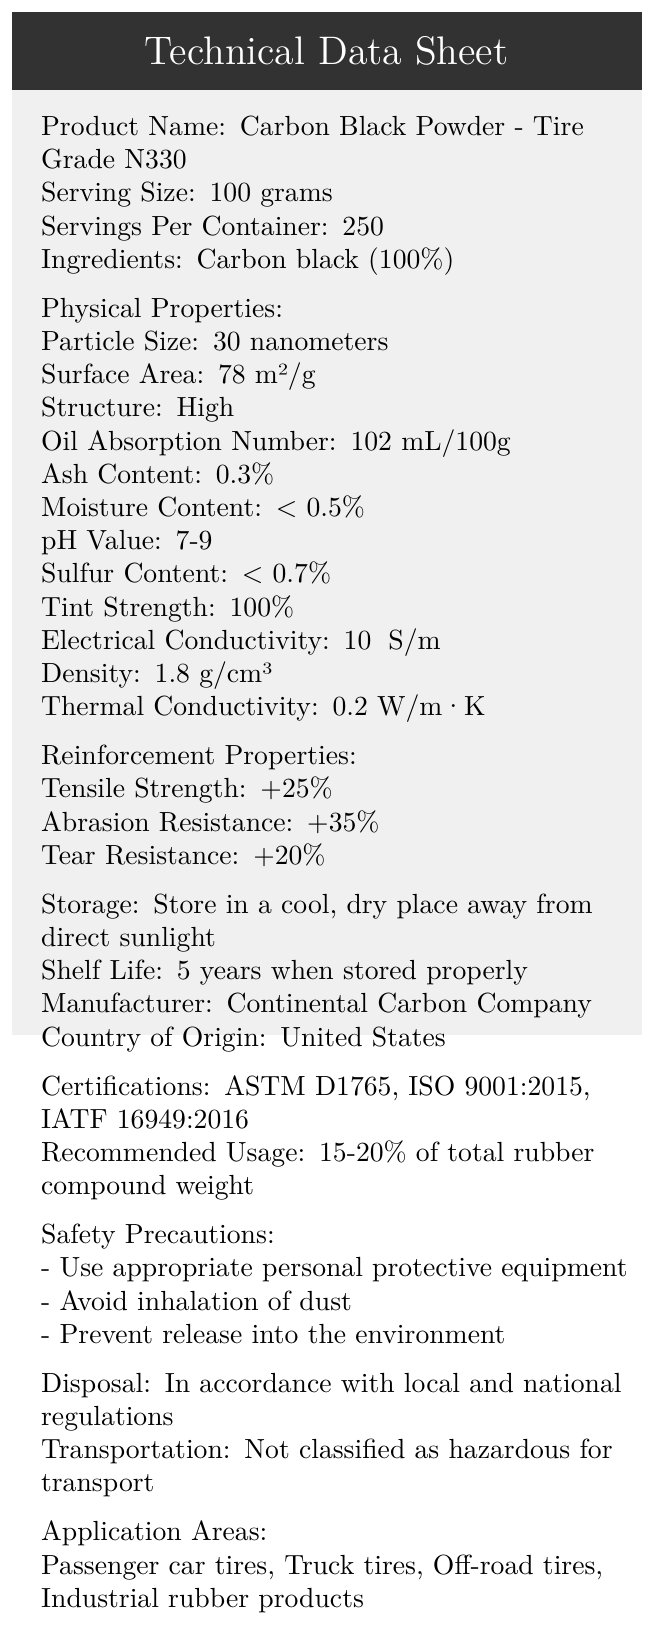what is the product name? The product name is clearly stated at the beginning of the document.
Answer: Carbon Black Powder - Tire Grade N330 what is the particle size of the carbon black powder? The particle size is specified in the document under the Physical Properties section.
Answer: 30 nanometers how many servings per container are there? The number of servings per container is listed near the top of the document.
Answer: 250 what is the recommended usage of carbon black powder in tire production? The recommended usage is mentioned in the document under the Recommended Usage section.
Answer: 15-20% of total rubber compound weight list the certifications that the product has received. The certifications are provided in the Certifications section of the document.
Answer: ASTM D1765, ISO 9001:2015, IATF 16949:2016 what is the thermal conductivity of the carbon black powder? A. 0.2 W/m·K B. 0.5 W/m·K C. 1.0 W/m·K D. 2.0 W/m·K The document lists the thermal conductivity as 0.2 W/m·K.
Answer: A who is the manufacturer of the product? A. Continental Carbon Company B. Michelin C. Goodyear D. Pirelli The manufacturer is listed as Continental Carbon Company.
Answer: A is the product classified as hazardous for transport? The document states that the product is not classified as hazardous for transport.
Answer: No what are the reinforcement properties of the carbon black powder related to tire performance? The reinforcement properties are provided in the Reinforcement Properties section.
Answer: Tensile Strength: +25%, Abrasion Resistance: +35%, Tear Resistance: +20% where should the product be stored? The storage instructions are detailed under the Storage section of the document.
Answer: In a cool, dry place away from direct sunlight summarize the main idea of the document. The main idea of the document is to supply all the essential technical and safety information about the product for its proper application in tire and rubber production.
Answer: The document provides a comprehensive technical data sheet for Carbon Black Powder - Tire Grade N330, detailing its physical properties, reinforcement properties, certifications, recommended usage, safety precautions, and storage conditions. what is the cost of the carbon black powder? The document does not provide any information about the cost or pricing of the carbon black powder.
Answer: Cannot be determined 